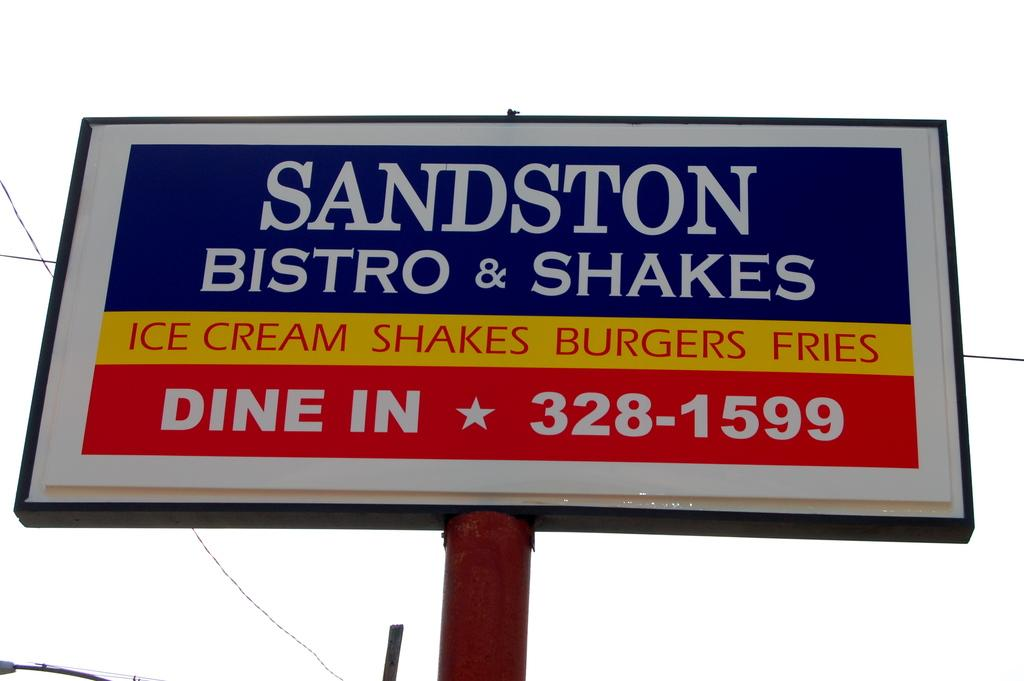<image>
Describe the image concisely. SIGNBOARD FOR A DINER CALLED SANDSTON BISTRO & SHAKES 